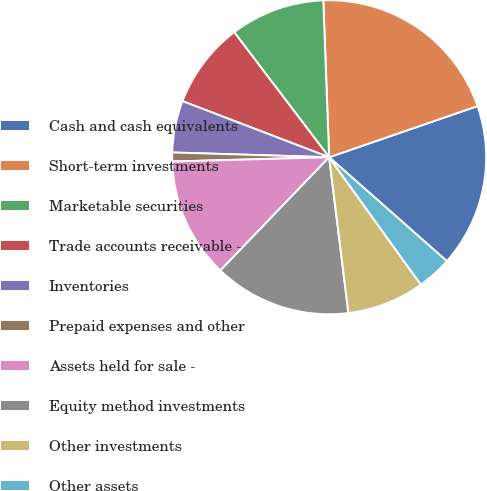<chart> <loc_0><loc_0><loc_500><loc_500><pie_chart><fcel>Cash and cash equivalents<fcel>Short-term investments<fcel>Marketable securities<fcel>Trade accounts receivable -<fcel>Inventories<fcel>Prepaid expenses and other<fcel>Assets held for sale -<fcel>Equity method investments<fcel>Other investments<fcel>Other assets<nl><fcel>16.79%<fcel>20.31%<fcel>9.74%<fcel>8.85%<fcel>5.33%<fcel>0.92%<fcel>12.38%<fcel>14.14%<fcel>7.97%<fcel>3.56%<nl></chart> 